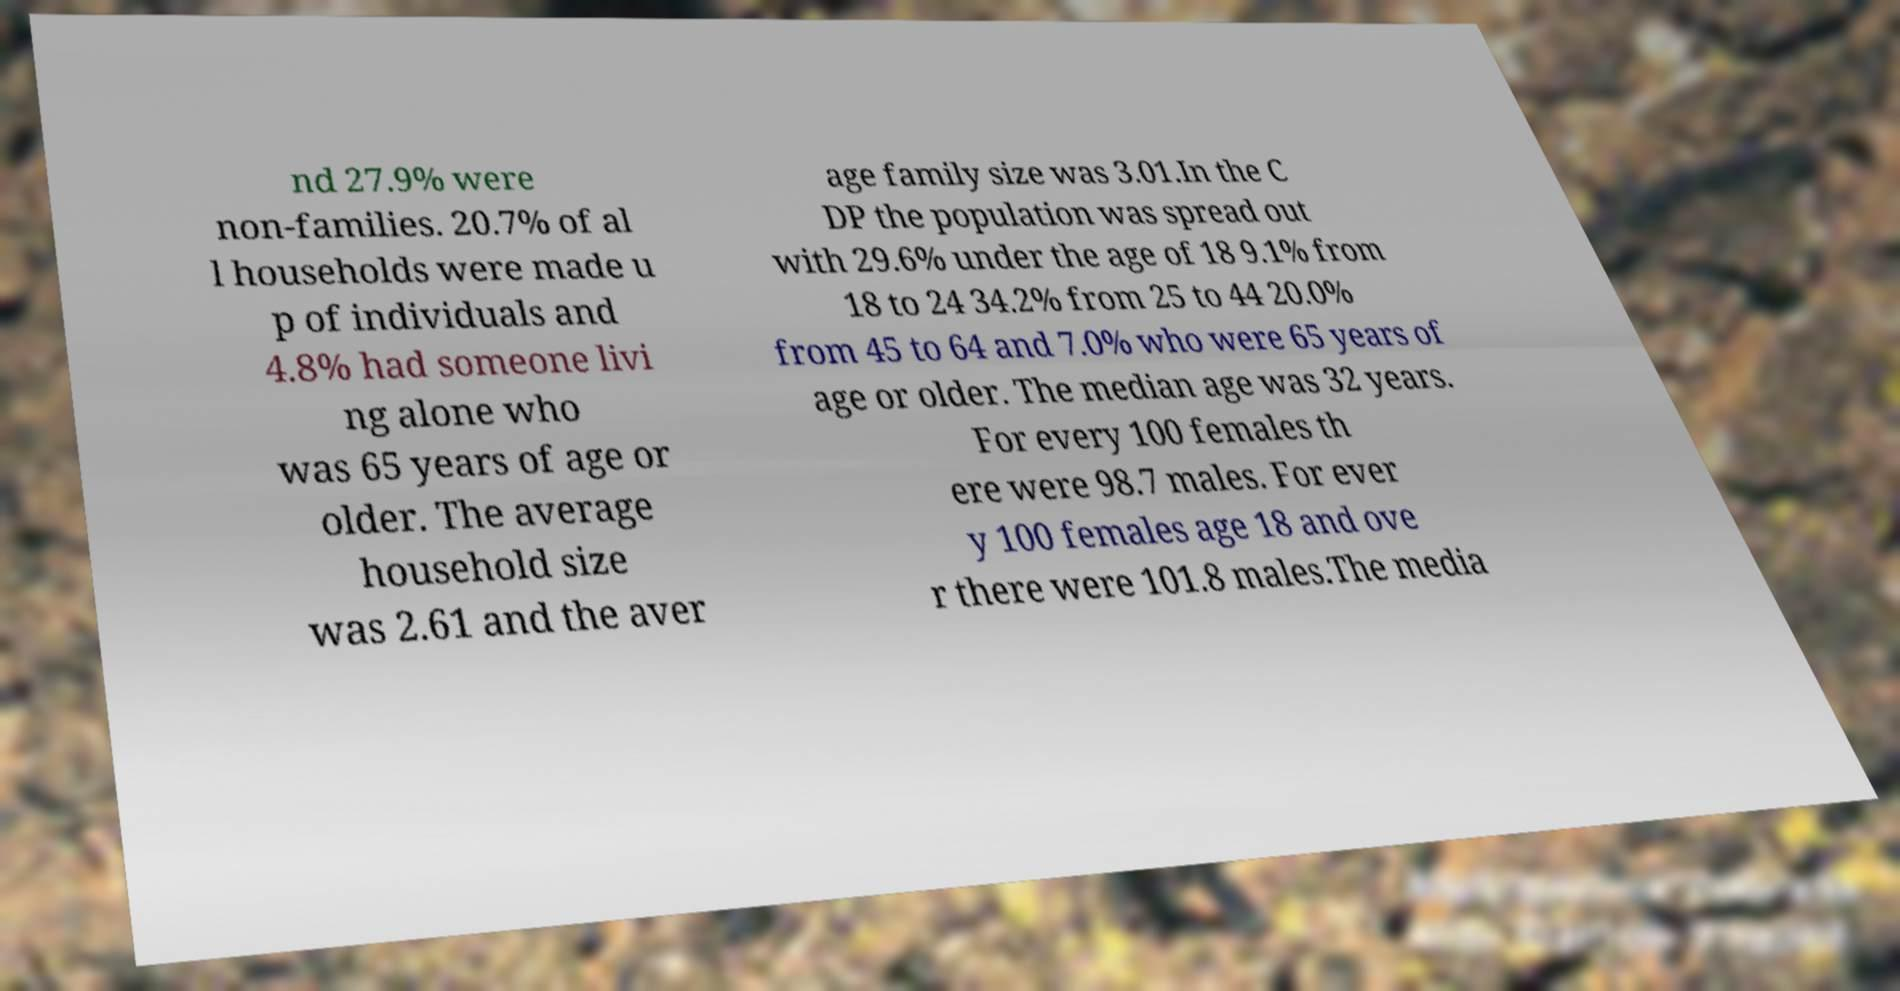For documentation purposes, I need the text within this image transcribed. Could you provide that? nd 27.9% were non-families. 20.7% of al l households were made u p of individuals and 4.8% had someone livi ng alone who was 65 years of age or older. The average household size was 2.61 and the aver age family size was 3.01.In the C DP the population was spread out with 29.6% under the age of 18 9.1% from 18 to 24 34.2% from 25 to 44 20.0% from 45 to 64 and 7.0% who were 65 years of age or older. The median age was 32 years. For every 100 females th ere were 98.7 males. For ever y 100 females age 18 and ove r there were 101.8 males.The media 